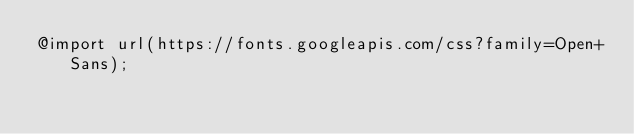Convert code to text. <code><loc_0><loc_0><loc_500><loc_500><_CSS_>@import url(https://fonts.googleapis.com/css?family=Open+Sans);</code> 